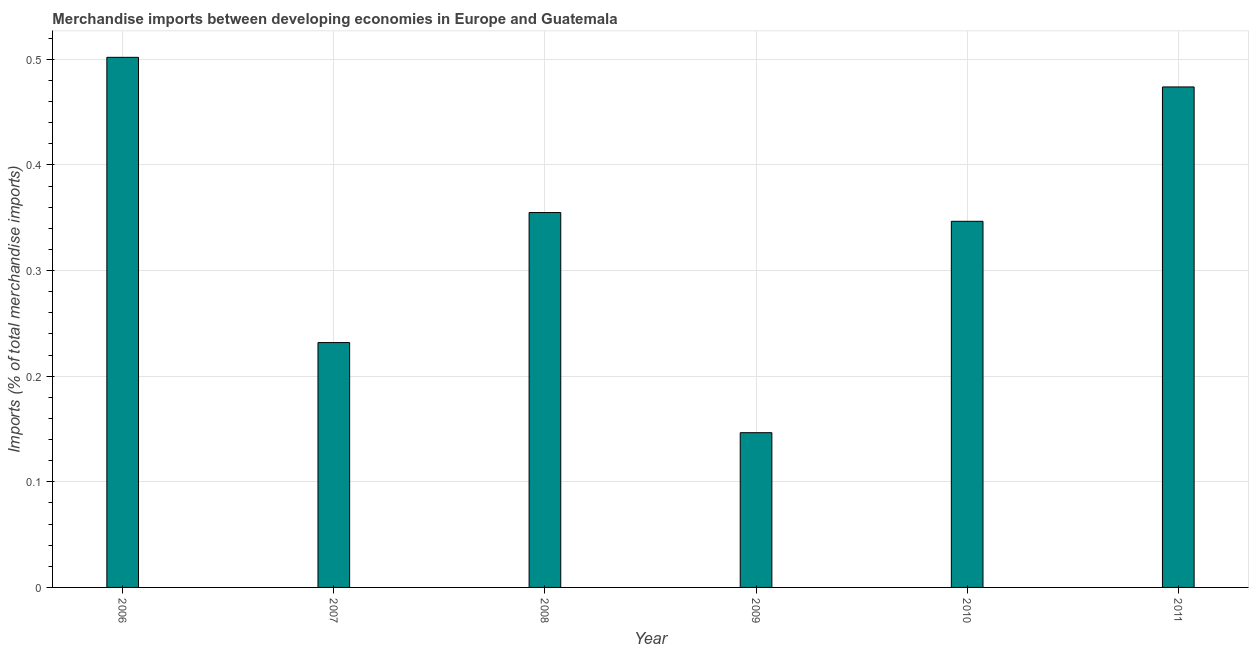Does the graph contain grids?
Make the answer very short. Yes. What is the title of the graph?
Your response must be concise. Merchandise imports between developing economies in Europe and Guatemala. What is the label or title of the Y-axis?
Offer a terse response. Imports (% of total merchandise imports). What is the merchandise imports in 2008?
Keep it short and to the point. 0.35. Across all years, what is the maximum merchandise imports?
Give a very brief answer. 0.5. Across all years, what is the minimum merchandise imports?
Offer a terse response. 0.15. In which year was the merchandise imports minimum?
Your answer should be very brief. 2009. What is the sum of the merchandise imports?
Make the answer very short. 2.06. What is the difference between the merchandise imports in 2006 and 2011?
Your answer should be compact. 0.03. What is the average merchandise imports per year?
Your answer should be very brief. 0.34. What is the median merchandise imports?
Provide a short and direct response. 0.35. Do a majority of the years between 2010 and 2007 (inclusive) have merchandise imports greater than 0.5 %?
Provide a short and direct response. Yes. What is the ratio of the merchandise imports in 2010 to that in 2011?
Your response must be concise. 0.73. Is the difference between the merchandise imports in 2008 and 2011 greater than the difference between any two years?
Your answer should be very brief. No. What is the difference between the highest and the second highest merchandise imports?
Your answer should be compact. 0.03. What is the difference between the highest and the lowest merchandise imports?
Offer a terse response. 0.36. In how many years, is the merchandise imports greater than the average merchandise imports taken over all years?
Your answer should be very brief. 4. How many years are there in the graph?
Provide a short and direct response. 6. What is the difference between two consecutive major ticks on the Y-axis?
Provide a succinct answer. 0.1. What is the Imports (% of total merchandise imports) of 2006?
Keep it short and to the point. 0.5. What is the Imports (% of total merchandise imports) in 2007?
Your answer should be very brief. 0.23. What is the Imports (% of total merchandise imports) in 2008?
Ensure brevity in your answer.  0.35. What is the Imports (% of total merchandise imports) of 2009?
Offer a very short reply. 0.15. What is the Imports (% of total merchandise imports) of 2010?
Provide a short and direct response. 0.35. What is the Imports (% of total merchandise imports) of 2011?
Your answer should be compact. 0.47. What is the difference between the Imports (% of total merchandise imports) in 2006 and 2007?
Your answer should be compact. 0.27. What is the difference between the Imports (% of total merchandise imports) in 2006 and 2008?
Your answer should be compact. 0.15. What is the difference between the Imports (% of total merchandise imports) in 2006 and 2009?
Ensure brevity in your answer.  0.36. What is the difference between the Imports (% of total merchandise imports) in 2006 and 2010?
Ensure brevity in your answer.  0.16. What is the difference between the Imports (% of total merchandise imports) in 2006 and 2011?
Give a very brief answer. 0.03. What is the difference between the Imports (% of total merchandise imports) in 2007 and 2008?
Your answer should be compact. -0.12. What is the difference between the Imports (% of total merchandise imports) in 2007 and 2009?
Give a very brief answer. 0.09. What is the difference between the Imports (% of total merchandise imports) in 2007 and 2010?
Keep it short and to the point. -0.11. What is the difference between the Imports (% of total merchandise imports) in 2007 and 2011?
Provide a succinct answer. -0.24. What is the difference between the Imports (% of total merchandise imports) in 2008 and 2009?
Ensure brevity in your answer.  0.21. What is the difference between the Imports (% of total merchandise imports) in 2008 and 2010?
Your answer should be compact. 0.01. What is the difference between the Imports (% of total merchandise imports) in 2008 and 2011?
Keep it short and to the point. -0.12. What is the difference between the Imports (% of total merchandise imports) in 2009 and 2010?
Provide a short and direct response. -0.2. What is the difference between the Imports (% of total merchandise imports) in 2009 and 2011?
Make the answer very short. -0.33. What is the difference between the Imports (% of total merchandise imports) in 2010 and 2011?
Ensure brevity in your answer.  -0.13. What is the ratio of the Imports (% of total merchandise imports) in 2006 to that in 2007?
Keep it short and to the point. 2.17. What is the ratio of the Imports (% of total merchandise imports) in 2006 to that in 2008?
Your answer should be compact. 1.41. What is the ratio of the Imports (% of total merchandise imports) in 2006 to that in 2009?
Make the answer very short. 3.43. What is the ratio of the Imports (% of total merchandise imports) in 2006 to that in 2010?
Offer a very short reply. 1.45. What is the ratio of the Imports (% of total merchandise imports) in 2006 to that in 2011?
Offer a terse response. 1.06. What is the ratio of the Imports (% of total merchandise imports) in 2007 to that in 2008?
Give a very brief answer. 0.65. What is the ratio of the Imports (% of total merchandise imports) in 2007 to that in 2009?
Offer a terse response. 1.58. What is the ratio of the Imports (% of total merchandise imports) in 2007 to that in 2010?
Offer a terse response. 0.67. What is the ratio of the Imports (% of total merchandise imports) in 2007 to that in 2011?
Provide a succinct answer. 0.49. What is the ratio of the Imports (% of total merchandise imports) in 2008 to that in 2009?
Make the answer very short. 2.42. What is the ratio of the Imports (% of total merchandise imports) in 2008 to that in 2010?
Provide a short and direct response. 1.02. What is the ratio of the Imports (% of total merchandise imports) in 2008 to that in 2011?
Provide a succinct answer. 0.75. What is the ratio of the Imports (% of total merchandise imports) in 2009 to that in 2010?
Your answer should be compact. 0.42. What is the ratio of the Imports (% of total merchandise imports) in 2009 to that in 2011?
Provide a short and direct response. 0.31. What is the ratio of the Imports (% of total merchandise imports) in 2010 to that in 2011?
Provide a succinct answer. 0.73. 